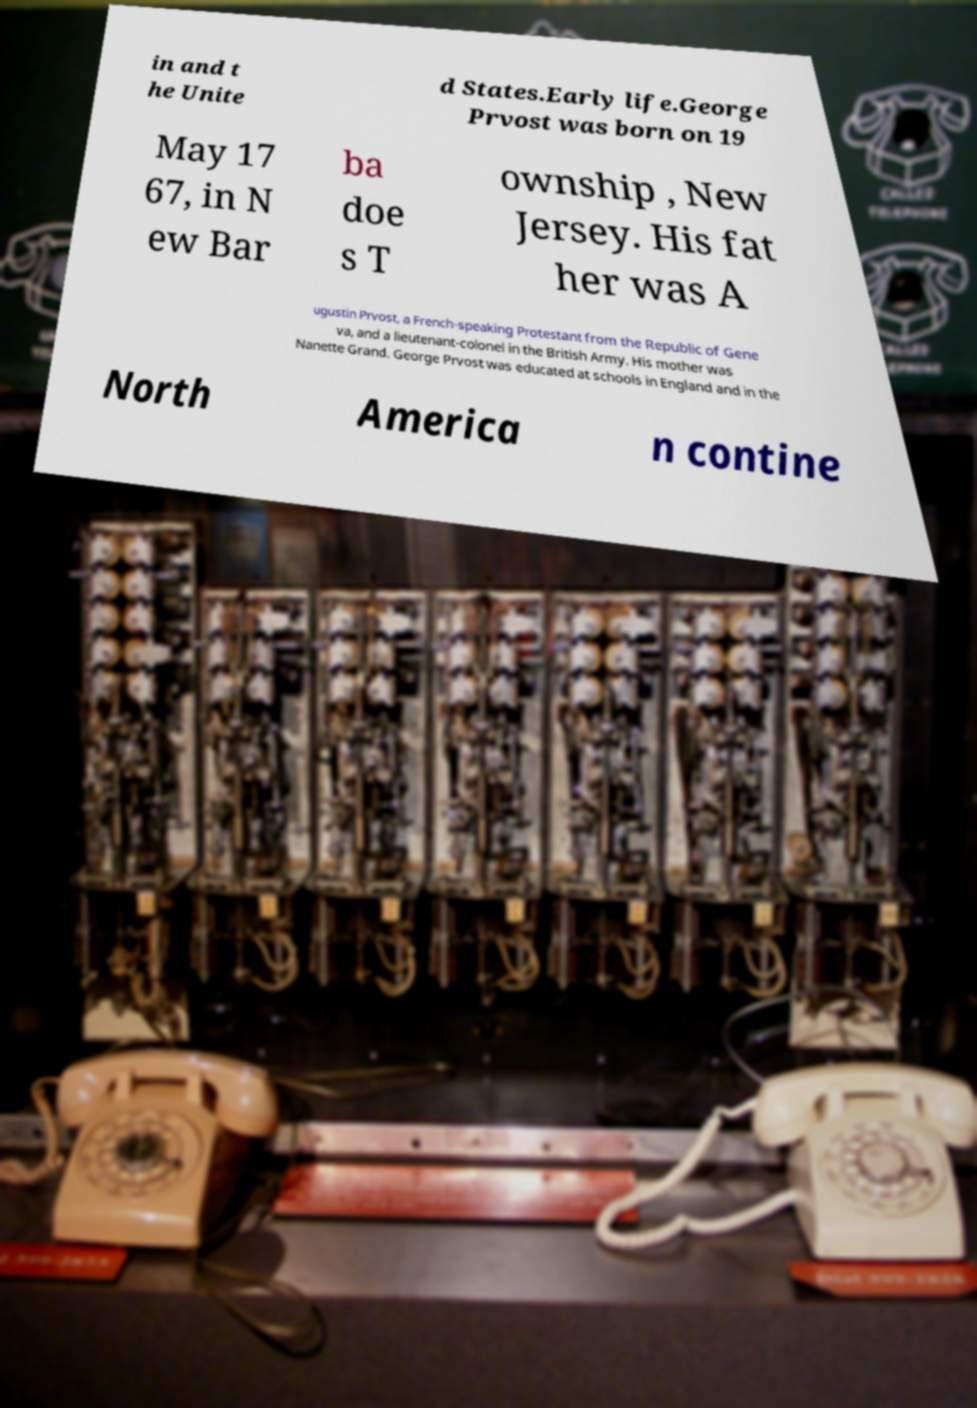Can you read and provide the text displayed in the image?This photo seems to have some interesting text. Can you extract and type it out for me? in and t he Unite d States.Early life.George Prvost was born on 19 May 17 67, in N ew Bar ba doe s T ownship , New Jersey. His fat her was A ugustin Prvost, a French-speaking Protestant from the Republic of Gene va, and a lieutenant-colonel in the British Army. His mother was Nanette Grand. George Prvost was educated at schools in England and in the North America n contine 